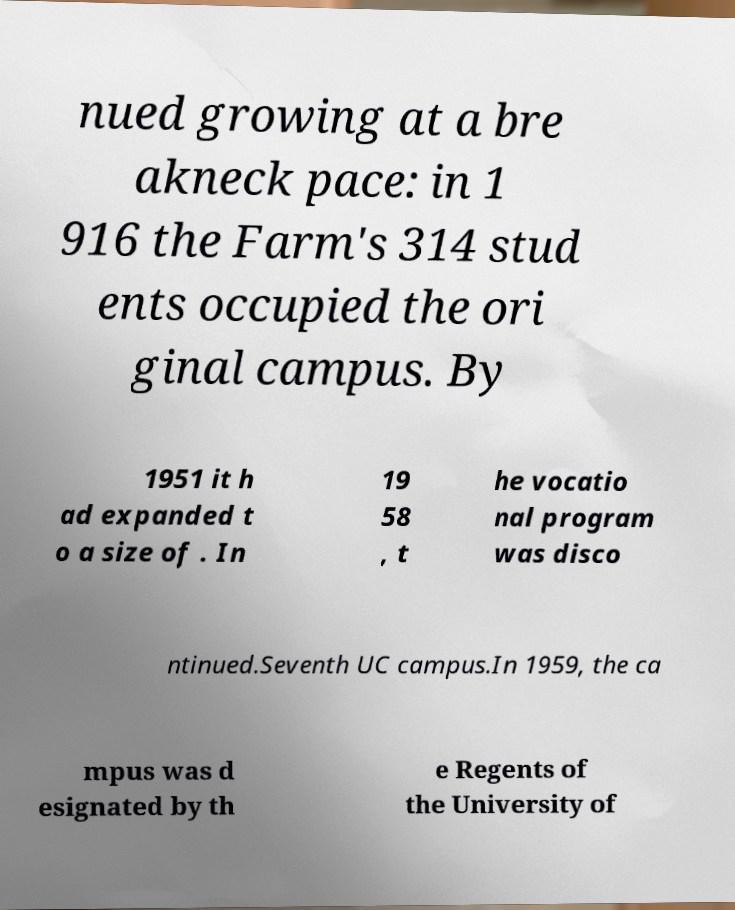Please read and relay the text visible in this image. What does it say? nued growing at a bre akneck pace: in 1 916 the Farm's 314 stud ents occupied the ori ginal campus. By 1951 it h ad expanded t o a size of . In 19 58 , t he vocatio nal program was disco ntinued.Seventh UC campus.In 1959, the ca mpus was d esignated by th e Regents of the University of 